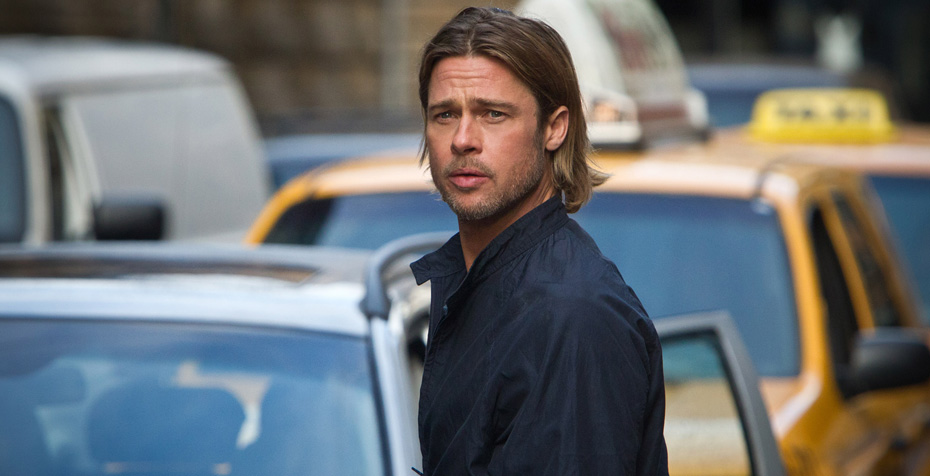Create a fictional backstory for the man in the image. Once a small-town mechanic, Jack Thompson moved to the big city fueled by dreams of becoming a renowned architect. After years of hard work and dedication, he finally secured his breakthrough project, designing a state-of-the-art skyscraper. However, balancing personal life and professional demands took a toll on him. The image captures Jack moments after an intense deliberation about a critical decision that will shape his career and personal life. His serious expression reflects the weight of his thoughts, as he remains determined to rise above the challenges that lie ahead. 